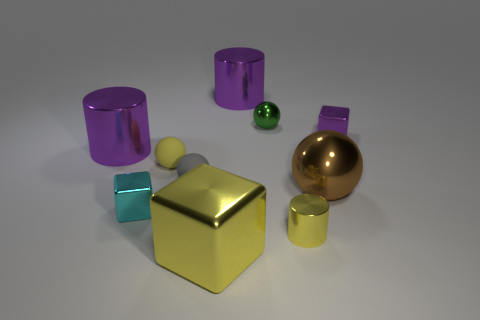What material is the yellow thing on the left side of the gray matte object to the left of the small yellow thing that is in front of the brown ball?
Offer a very short reply. Rubber. Is there a yellow shiny thing of the same size as the yellow shiny cylinder?
Your answer should be compact. No. There is a big cylinder that is behind the metal thing that is to the right of the large shiny ball; what color is it?
Make the answer very short. Purple. How many balls are there?
Ensure brevity in your answer.  4. Do the big cube and the tiny shiny cylinder have the same color?
Offer a very short reply. Yes. Are there fewer green objects that are in front of the large yellow cube than blocks on the left side of the yellow ball?
Ensure brevity in your answer.  Yes. What color is the big shiny sphere?
Offer a terse response. Brown. What number of objects are the same color as the large shiny block?
Ensure brevity in your answer.  2. There is a purple cube; are there any large metallic cylinders in front of it?
Your answer should be compact. Yes. Is the number of tiny yellow rubber things in front of the small gray matte object the same as the number of large shiny things that are in front of the cyan shiny thing?
Give a very brief answer. No. 